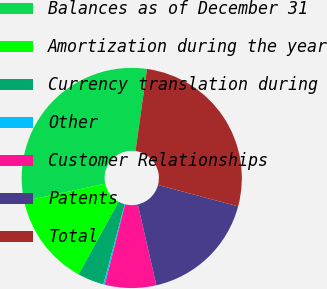Convert chart to OTSL. <chart><loc_0><loc_0><loc_500><loc_500><pie_chart><fcel>Balances as of December 31<fcel>Amortization during the year<fcel>Currency translation during<fcel>Other<fcel>Customer Relationships<fcel>Patents<fcel>Total<nl><fcel>30.58%<fcel>13.62%<fcel>3.87%<fcel>0.22%<fcel>7.51%<fcel>17.26%<fcel>26.94%<nl></chart> 